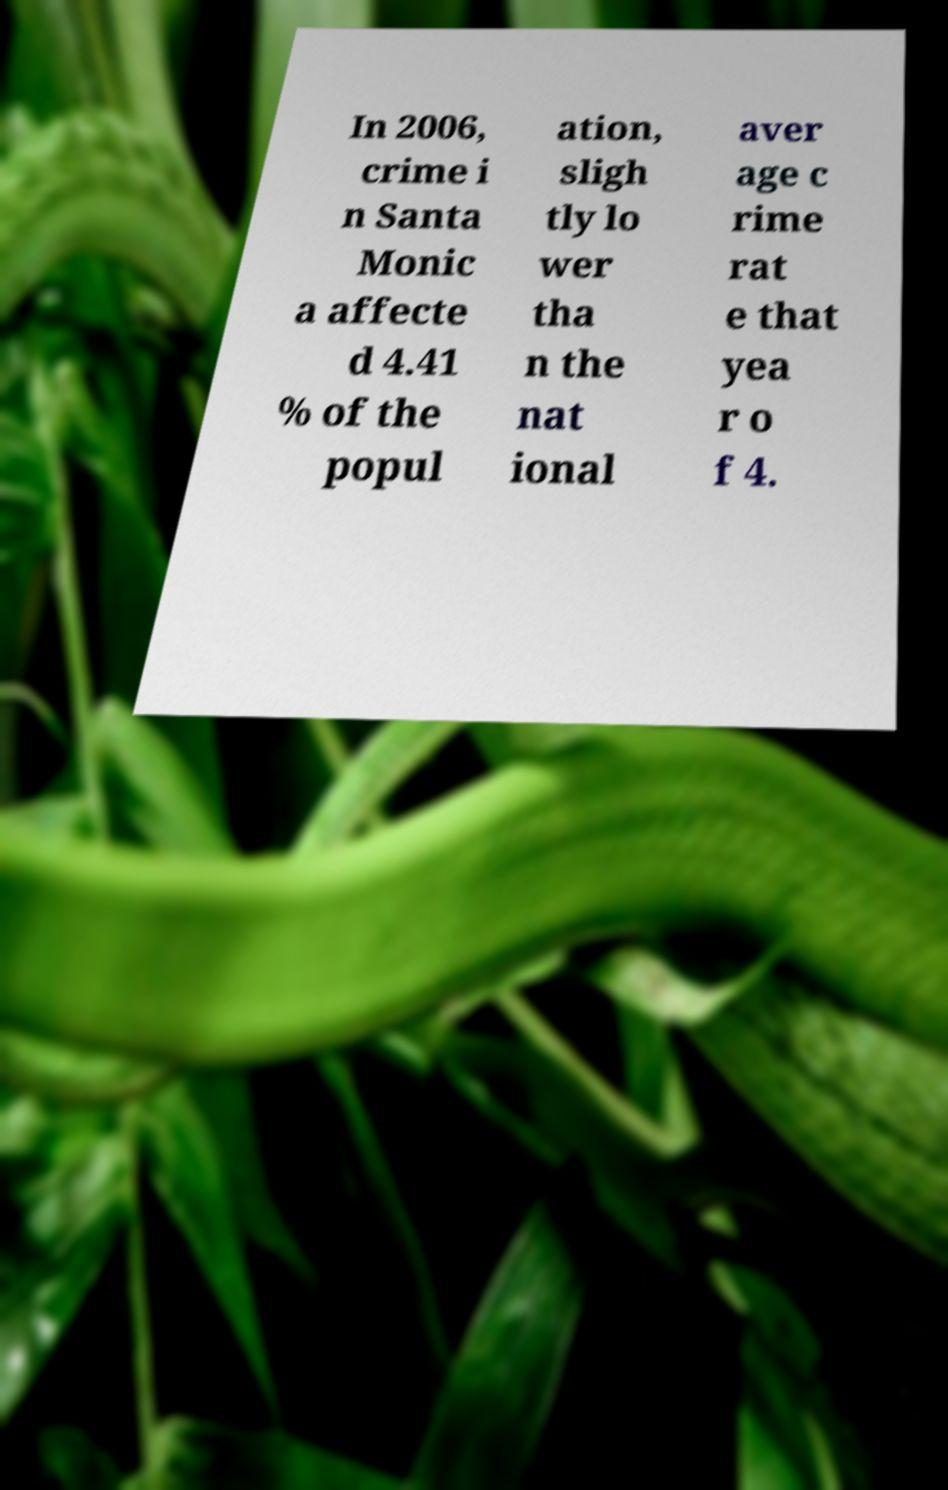Please identify and transcribe the text found in this image. In 2006, crime i n Santa Monic a affecte d 4.41 % of the popul ation, sligh tly lo wer tha n the nat ional aver age c rime rat e that yea r o f 4. 